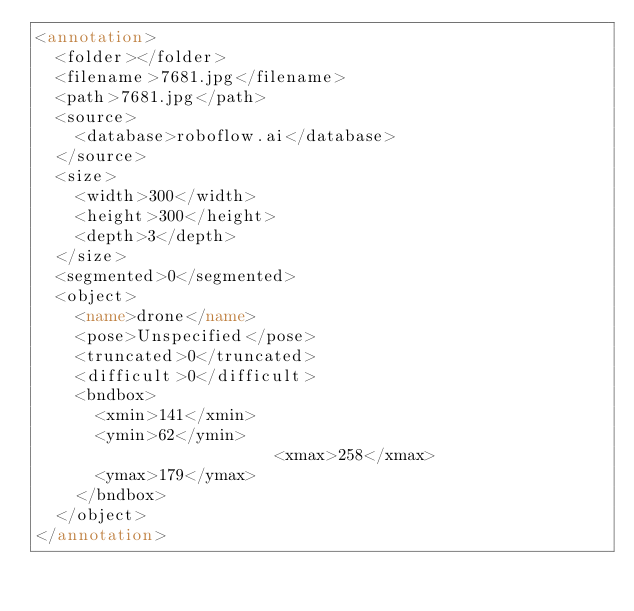<code> <loc_0><loc_0><loc_500><loc_500><_XML_><annotation>
	<folder></folder>
	<filename>7681.jpg</filename>
	<path>7681.jpg</path>
	<source>
		<database>roboflow.ai</database>
	</source>
	<size>
		<width>300</width>
		<height>300</height>
		<depth>3</depth>
	</size>
	<segmented>0</segmented>
	<object>
		<name>drone</name>
		<pose>Unspecified</pose>
		<truncated>0</truncated>
		<difficult>0</difficult>
		<bndbox>
			<xmin>141</xmin>
			<ymin>62</ymin>
                        <xmax>258</xmax>
			<ymax>179</ymax>
		</bndbox>
	</object>
</annotation>
</code> 